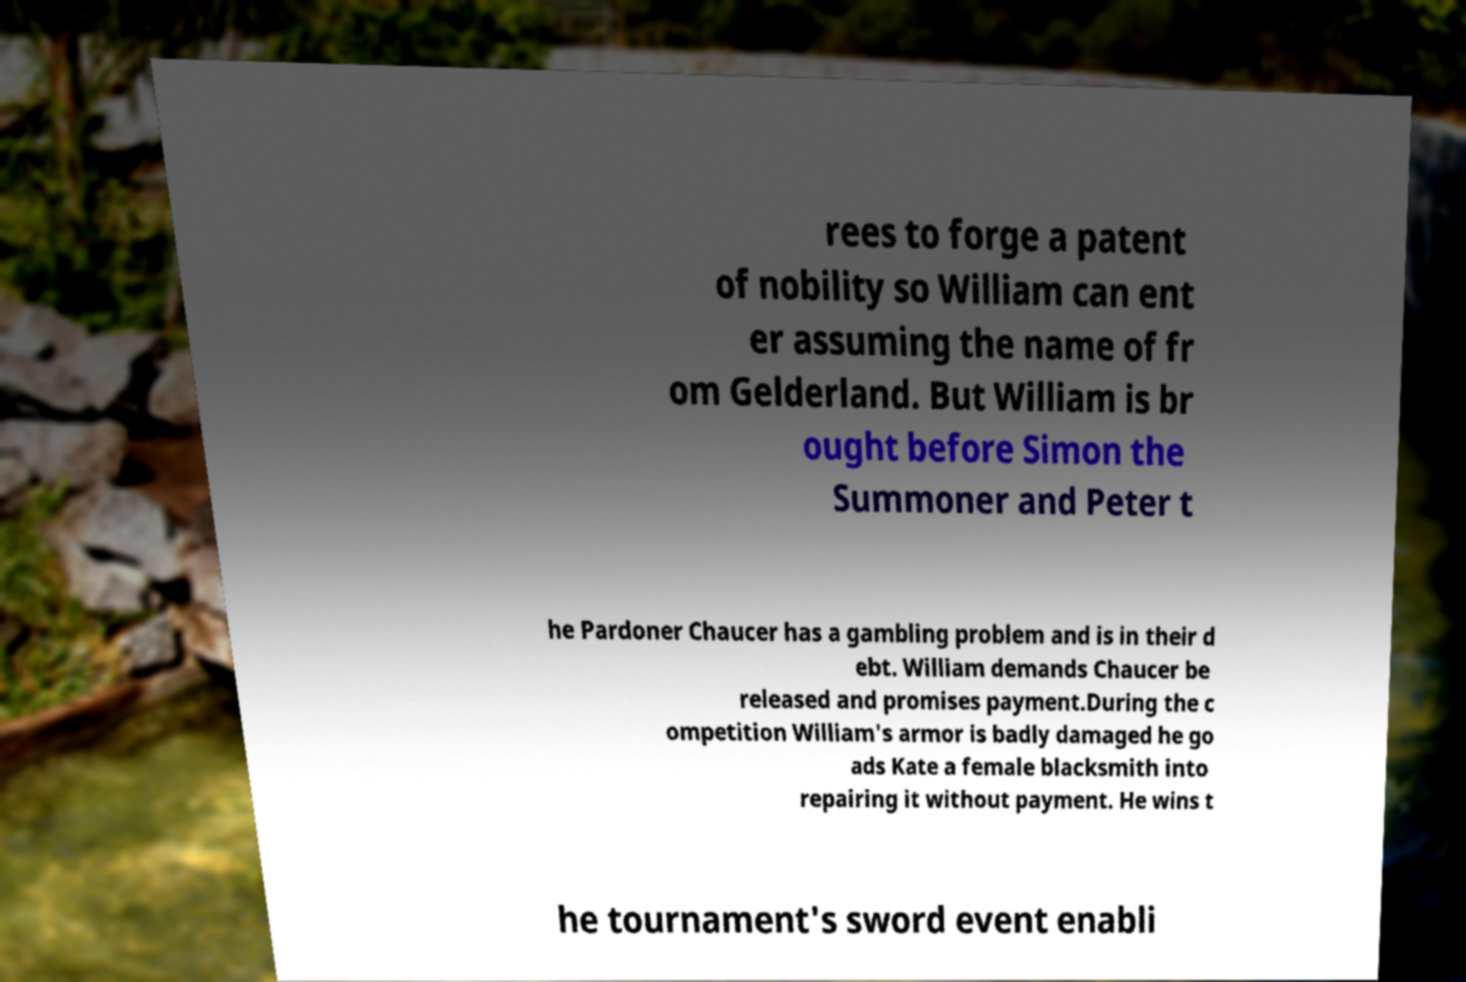Could you extract and type out the text from this image? rees to forge a patent of nobility so William can ent er assuming the name of fr om Gelderland. But William is br ought before Simon the Summoner and Peter t he Pardoner Chaucer has a gambling problem and is in their d ebt. William demands Chaucer be released and promises payment.During the c ompetition William's armor is badly damaged he go ads Kate a female blacksmith into repairing it without payment. He wins t he tournament's sword event enabli 